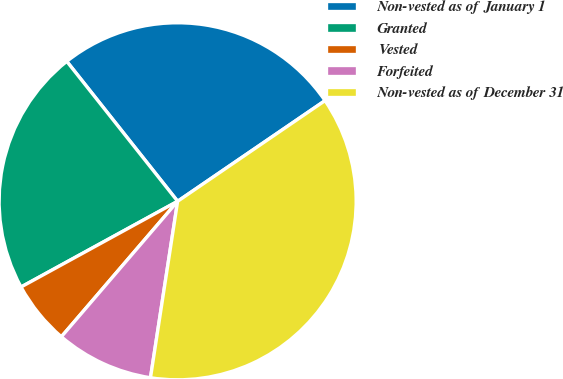Convert chart to OTSL. <chart><loc_0><loc_0><loc_500><loc_500><pie_chart><fcel>Non-vested as of January 1<fcel>Granted<fcel>Vested<fcel>Forfeited<fcel>Non-vested as of December 31<nl><fcel>26.13%<fcel>22.31%<fcel>5.74%<fcel>8.86%<fcel>36.97%<nl></chart> 